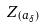Convert formula to latex. <formula><loc_0><loc_0><loc_500><loc_500>Z _ { ( a _ { \delta } ) }</formula> 